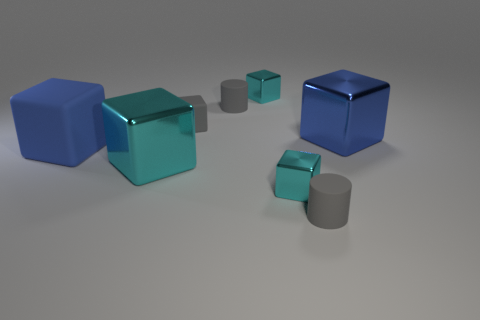Subtract all cyan blocks. How many were subtracted if there are2cyan blocks left? 1 Add 1 big green things. How many objects exist? 9 Subtract all large blue cubes. How many cubes are left? 4 Subtract 4 cubes. How many cubes are left? 2 Subtract all yellow cubes. Subtract all green spheres. How many cubes are left? 6 Subtract all blue cylinders. How many gray cubes are left? 1 Subtract all large blocks. Subtract all yellow cubes. How many objects are left? 5 Add 7 matte cubes. How many matte cubes are left? 9 Add 6 tiny metal things. How many tiny metal things exist? 8 Subtract all blue blocks. How many blocks are left? 4 